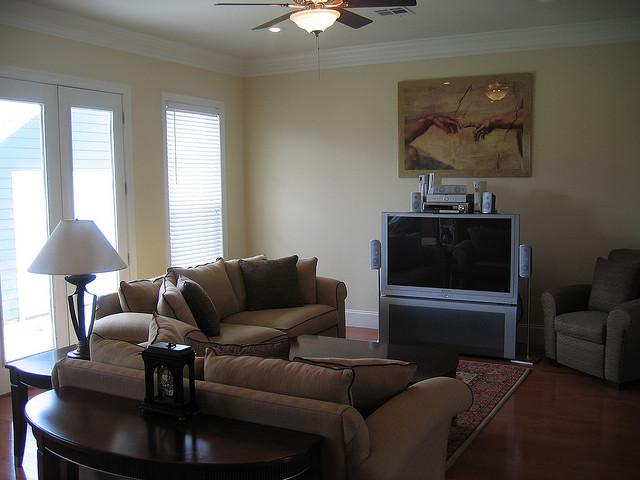What color is the TV in the living room?
Quick response, please. Silver. How many sofas are pictured?
Quick response, please. 2. Is it daytime?
Concise answer only. Yes. Why is the television off?
Give a very brief answer. Nobody is watching. How many couches are there?
Quick response, please. 2. Where are the external speakers?
Quick response, please. Side of tv. Is the TV on?
Give a very brief answer. No. Is there an animal in the picture?
Keep it brief. No. What is the back wall made of?
Write a very short answer. Drywall. What is sitting on the table?
Quick response, please. Clock. Which room of a household does this picture depict?
Concise answer only. Living room. 